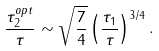<formula> <loc_0><loc_0><loc_500><loc_500>\frac { \tau _ { 2 } ^ { o p t } } { \tau } \sim \sqrt { \frac { 7 } { 4 } } \left ( \frac { \tau _ { 1 } } { \tau } \right ) ^ { 3 / 4 } .</formula> 